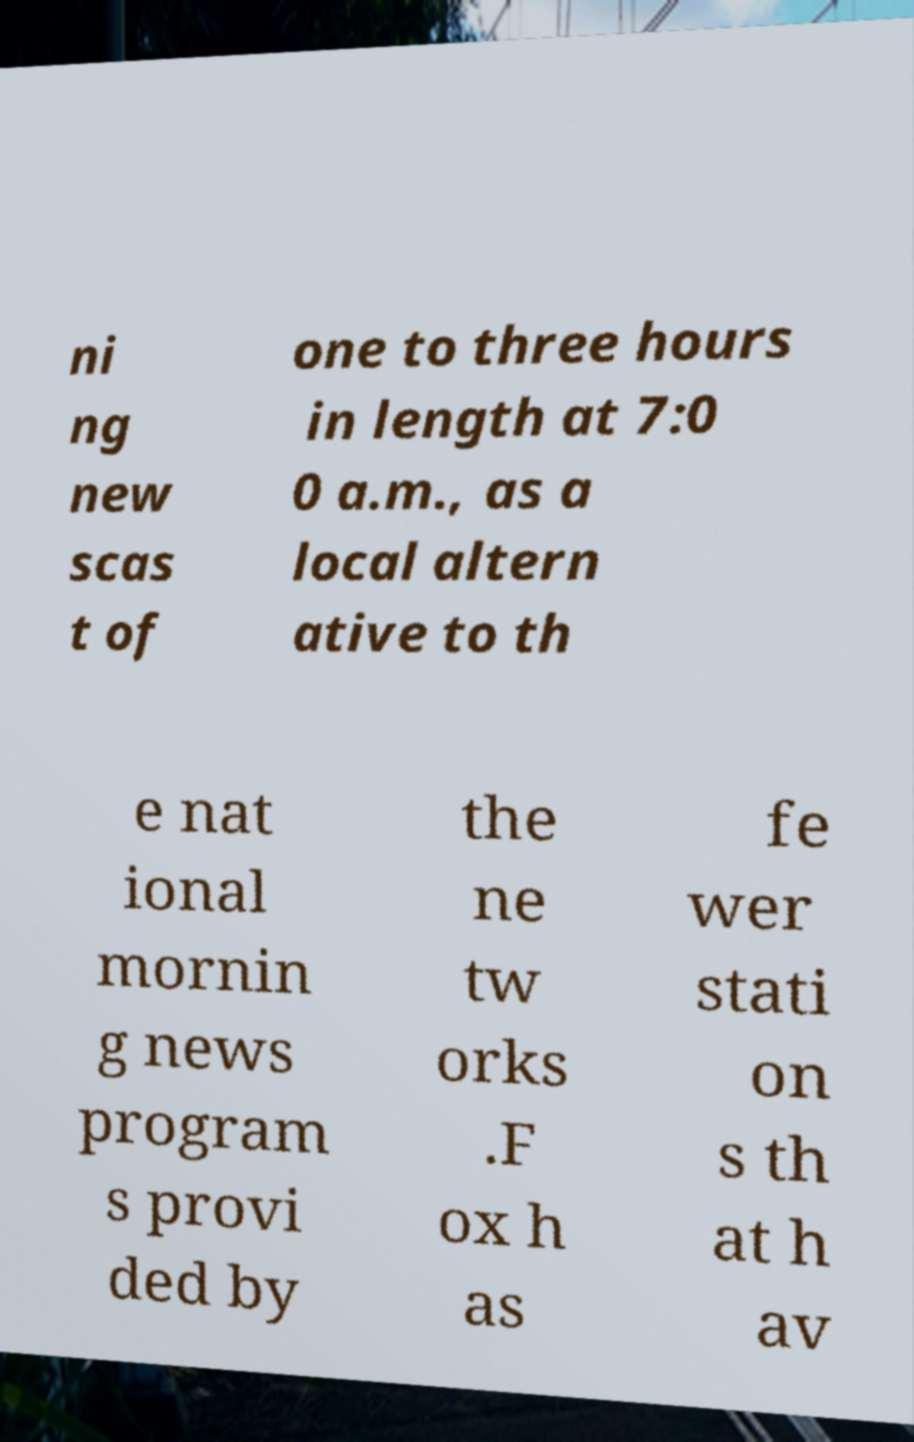Can you read and provide the text displayed in the image?This photo seems to have some interesting text. Can you extract and type it out for me? ni ng new scas t of one to three hours in length at 7:0 0 a.m., as a local altern ative to th e nat ional mornin g news program s provi ded by the ne tw orks .F ox h as fe wer stati on s th at h av 